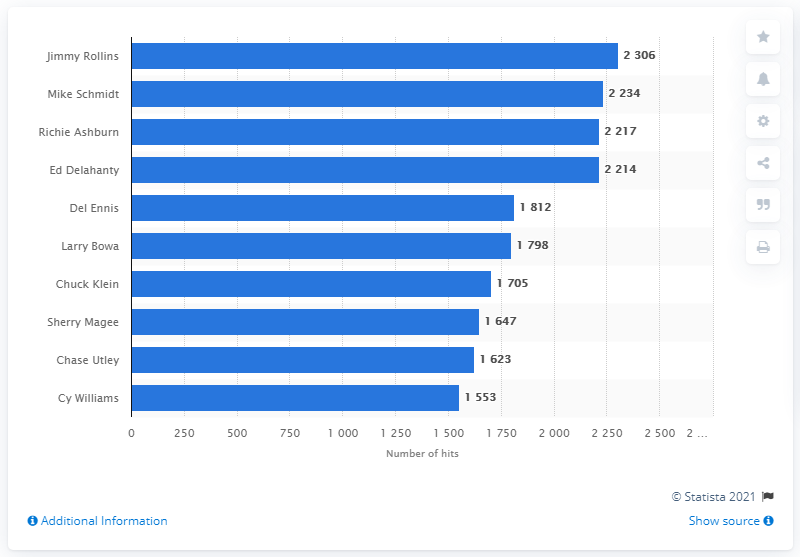Outline some significant characteristics in this image. Jimmy Rollins holds the record for the most hits in the history of the Phillies franchise. 